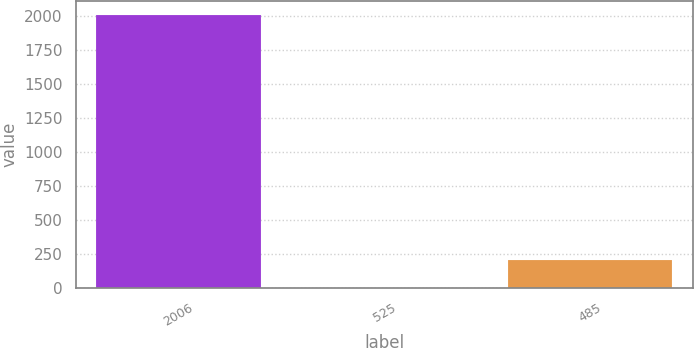Convert chart. <chart><loc_0><loc_0><loc_500><loc_500><bar_chart><fcel>2006<fcel>525<fcel>485<nl><fcel>2005<fcel>4.25<fcel>204.33<nl></chart> 